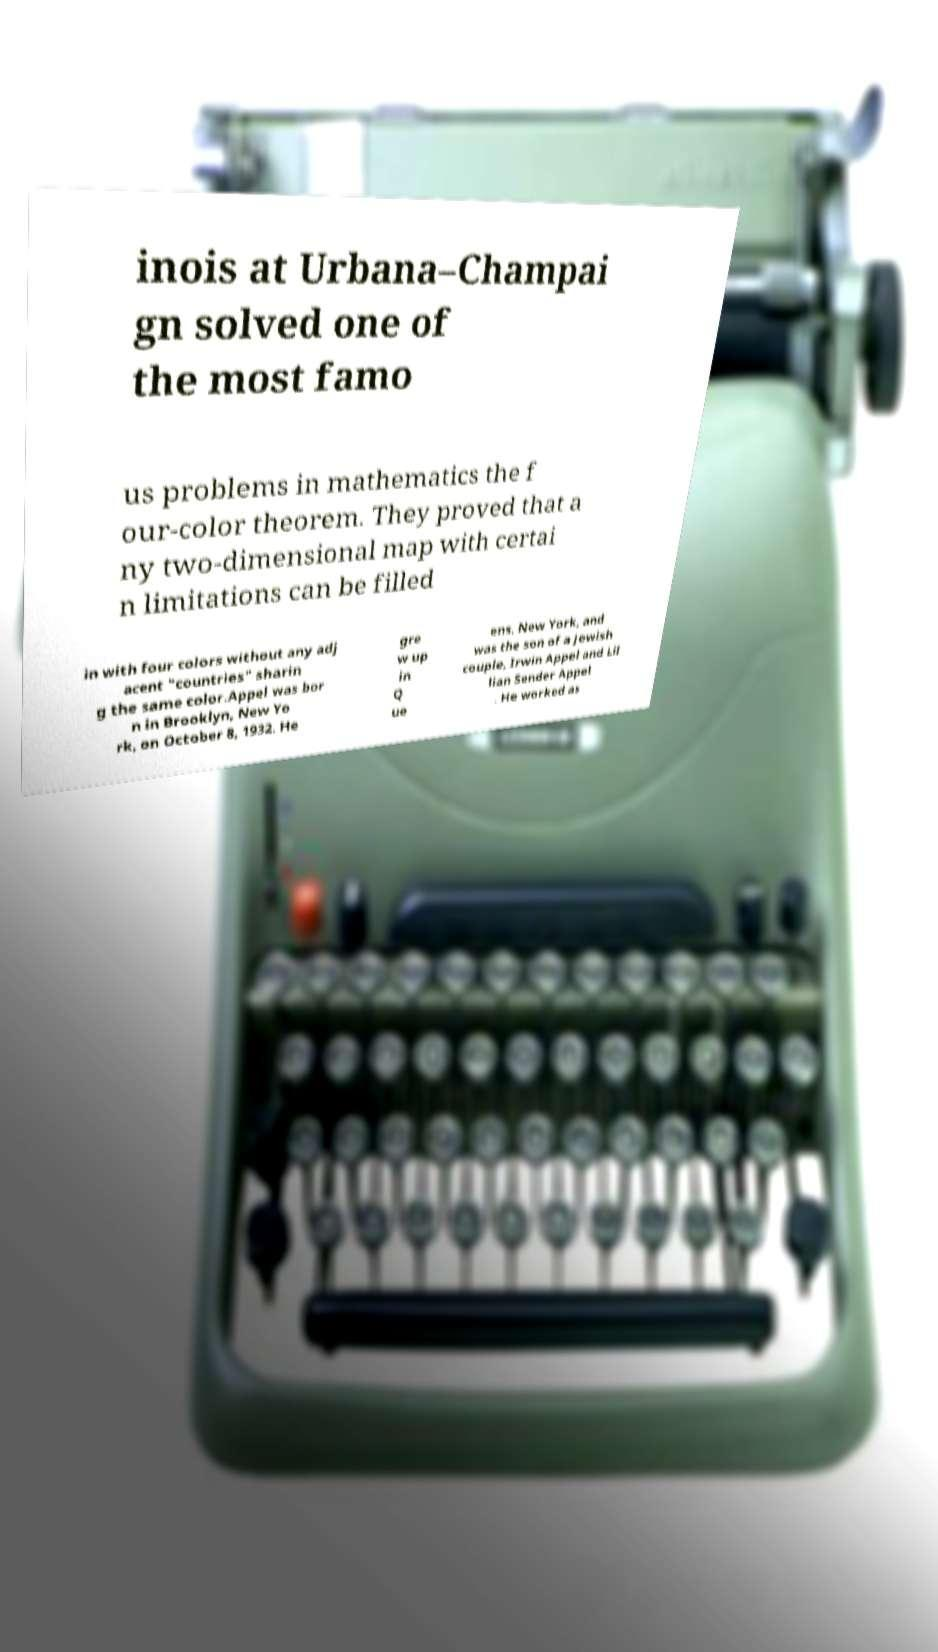There's text embedded in this image that I need extracted. Can you transcribe it verbatim? inois at Urbana–Champai gn solved one of the most famo us problems in mathematics the f our-color theorem. They proved that a ny two-dimensional map with certai n limitations can be filled in with four colors without any adj acent "countries" sharin g the same color.Appel was bor n in Brooklyn, New Yo rk, on October 8, 1932. He gre w up in Q ue ens, New York, and was the son of a Jewish couple, Irwin Appel and Lil lian Sender Appel . He worked as 